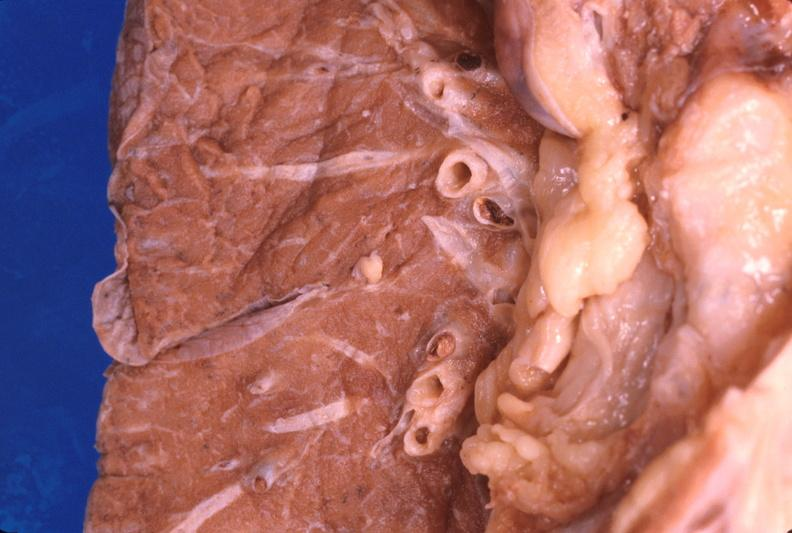does this image show thromboembolus from leg veins in pulmonary artery?
Answer the question using a single word or phrase. Yes 